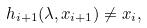Convert formula to latex. <formula><loc_0><loc_0><loc_500><loc_500>h _ { i + 1 } ( \lambda , x _ { i + 1 } ) \neq x _ { i } ,</formula> 